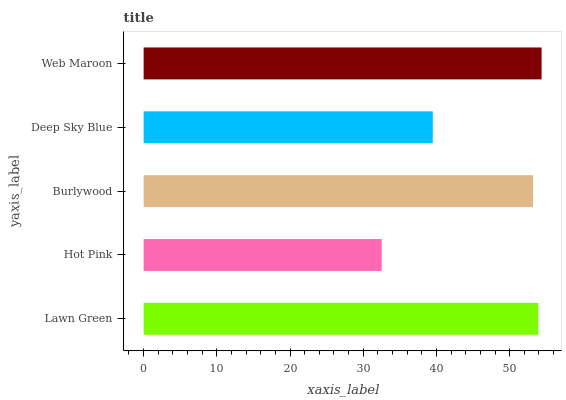Is Hot Pink the minimum?
Answer yes or no. Yes. Is Web Maroon the maximum?
Answer yes or no. Yes. Is Burlywood the minimum?
Answer yes or no. No. Is Burlywood the maximum?
Answer yes or no. No. Is Burlywood greater than Hot Pink?
Answer yes or no. Yes. Is Hot Pink less than Burlywood?
Answer yes or no. Yes. Is Hot Pink greater than Burlywood?
Answer yes or no. No. Is Burlywood less than Hot Pink?
Answer yes or no. No. Is Burlywood the high median?
Answer yes or no. Yes. Is Burlywood the low median?
Answer yes or no. Yes. Is Hot Pink the high median?
Answer yes or no. No. Is Deep Sky Blue the low median?
Answer yes or no. No. 